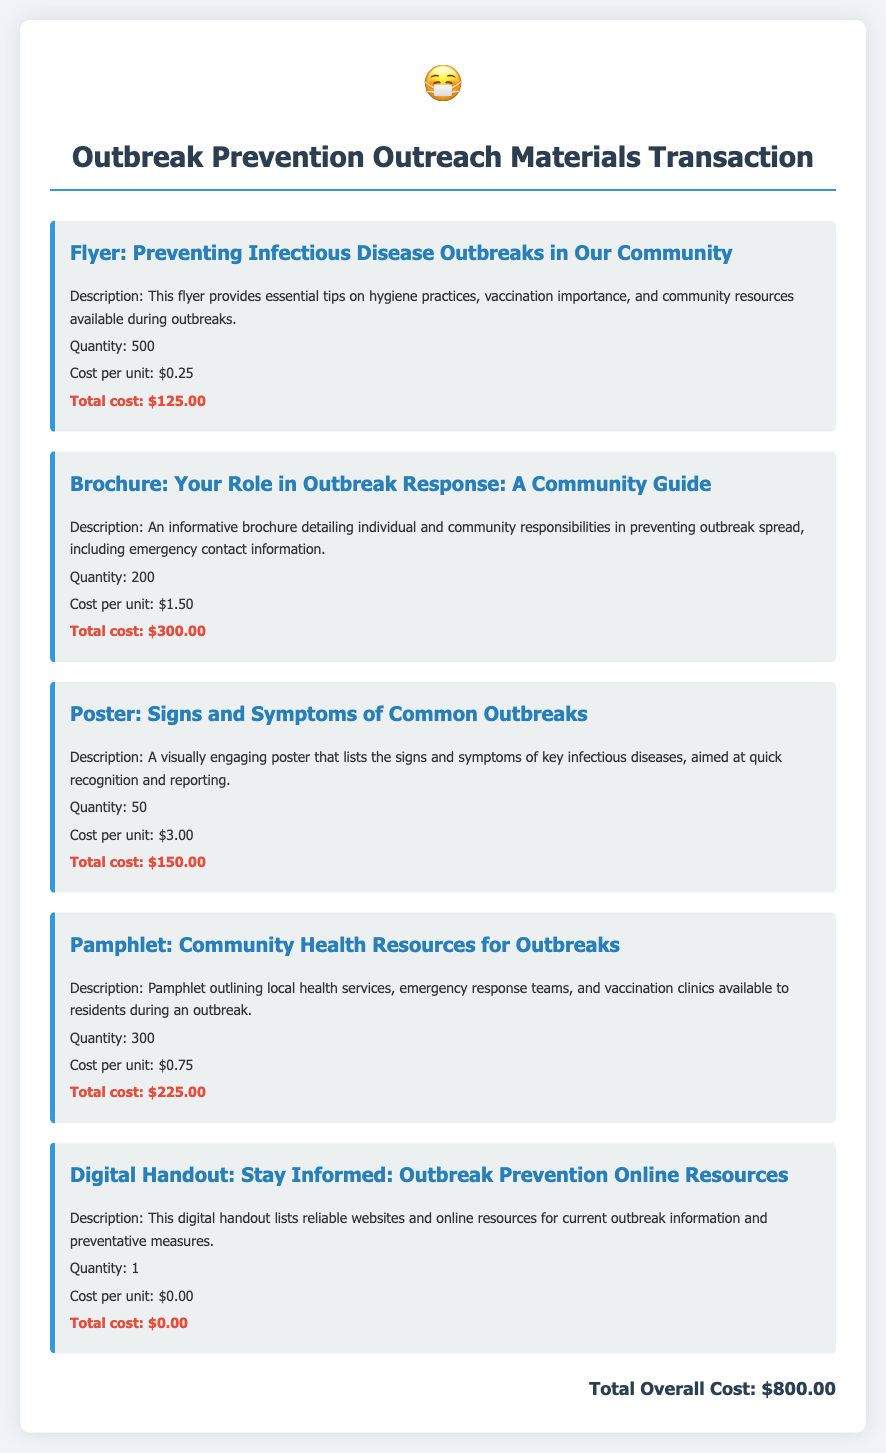What is the total overall cost? The total overall cost is listed at the bottom of the document and includes all materials ordered, which totals $800.00.
Answer: $800.00 How many flyers were ordered? The document specifies that a total of 500 flyers were ordered for outreach on outbreak prevention.
Answer: 500 What is the cost per unit of the brochure? The cost per unit for the brochure entitled "Your Role in Outbreak Response: A Community Guide" is mentioned as $1.50.
Answer: $1.50 What is the quantity of posters ordered? The quantity of posters titled "Signs and Symptoms of Common Outbreaks" is stated as 50.
Answer: 50 What is the total cost for the pamphlet? The total cost for the pamphlet "Community Health Resources for Outbreaks" can be calculated by multiplying the quantity (300) by the cost per unit ($0.75), resulting in $225.00.
Answer: $225.00 What is the description of the digital handout? The document describes the digital handout as containing reliable websites and resources for outbreak information and preventative measures.
Answer: Lists reliable websites and online resources Which material has the highest cost per unit? By comparing the costs per unit of all materials, the poster has the highest cost per unit at $3.00.
Answer: Poster What is the total quantity of materials ordered? The total quantity can be obtained by adding all quantities from each material type: 500 + 200 + 50 + 300 + 1 = 1051.
Answer: 1051 What is the title of the pamphlet? The title of the pamphlet providing information on local health services is "Community Health Resources for Outbreaks."
Answer: Community Health Resources for Outbreaks 